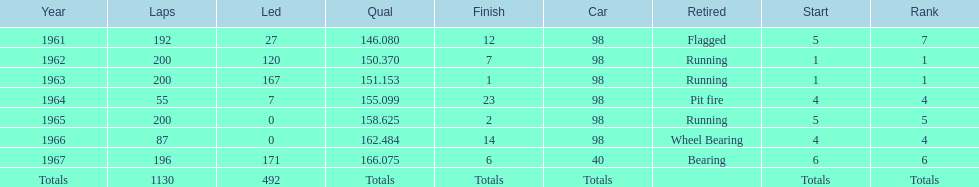What is the difference between the qualfying time in 1967 and 1965? 7.45. 